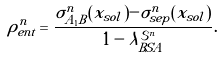Convert formula to latex. <formula><loc_0><loc_0><loc_500><loc_500>\rho _ { e n t } ^ { n } = \frac { \sigma _ { A _ { 1 } B } ^ { n } ( { x } _ { s o l } ) - \sigma _ { s e p } ^ { n } ( { x } _ { s o l } ) } { 1 - \lambda _ { B S A } ^ { \mathcal { S } ^ { n } } } .</formula> 